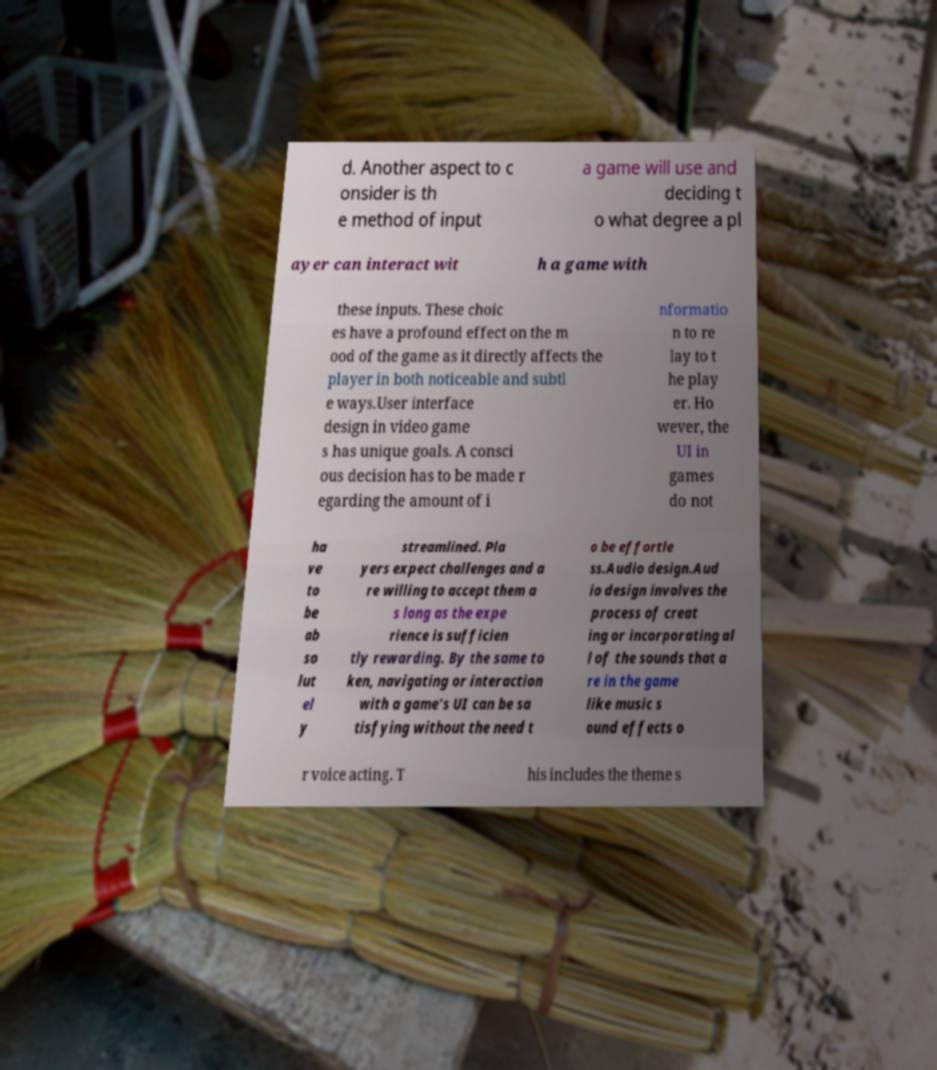Can you read and provide the text displayed in the image?This photo seems to have some interesting text. Can you extract and type it out for me? d. Another aspect to c onsider is th e method of input a game will use and deciding t o what degree a pl ayer can interact wit h a game with these inputs. These choic es have a profound effect on the m ood of the game as it directly affects the player in both noticeable and subtl e ways.User interface design in video game s has unique goals. A consci ous decision has to be made r egarding the amount of i nformatio n to re lay to t he play er. Ho wever, the UI in games do not ha ve to be ab so lut el y streamlined. Pla yers expect challenges and a re willing to accept them a s long as the expe rience is sufficien tly rewarding. By the same to ken, navigating or interaction with a game's UI can be sa tisfying without the need t o be effortle ss.Audio design.Aud io design involves the process of creat ing or incorporating al l of the sounds that a re in the game like music s ound effects o r voice acting. T his includes the theme s 